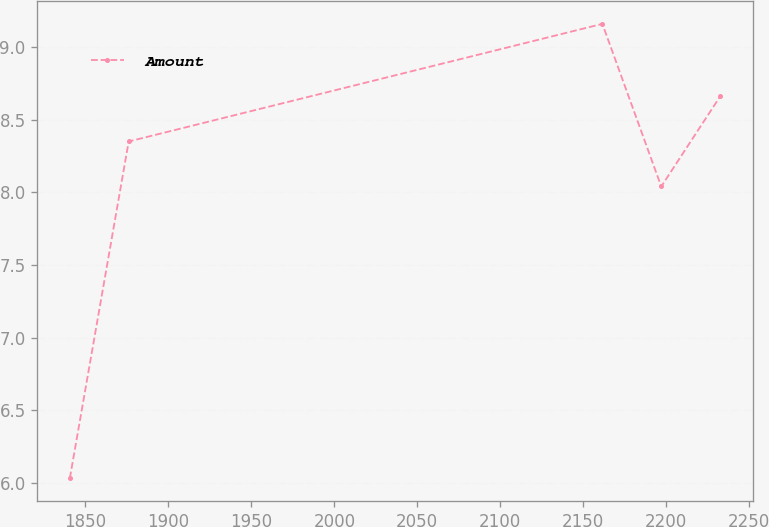<chart> <loc_0><loc_0><loc_500><loc_500><line_chart><ecel><fcel>Amount<nl><fcel>1840.65<fcel>6.03<nl><fcel>1876.12<fcel>8.35<nl><fcel>2161.5<fcel>9.16<nl><fcel>2196.97<fcel>8.04<nl><fcel>2232.44<fcel>8.66<nl></chart> 